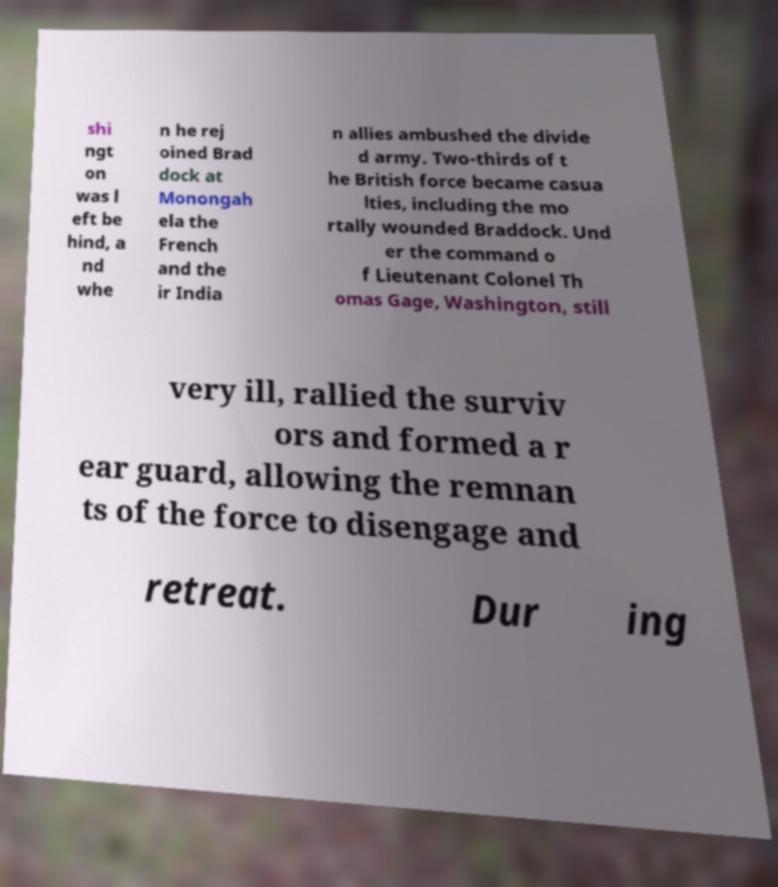Please identify and transcribe the text found in this image. shi ngt on was l eft be hind, a nd whe n he rej oined Brad dock at Monongah ela the French and the ir India n allies ambushed the divide d army. Two-thirds of t he British force became casua lties, including the mo rtally wounded Braddock. Und er the command o f Lieutenant Colonel Th omas Gage, Washington, still very ill, rallied the surviv ors and formed a r ear guard, allowing the remnan ts of the force to disengage and retreat. Dur ing 